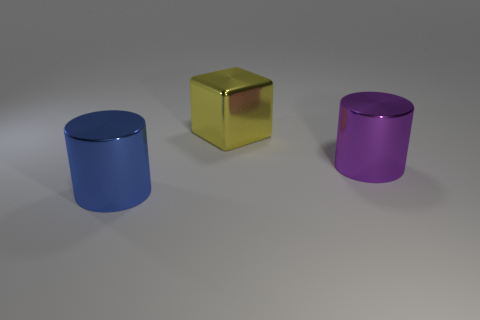Add 1 yellow cylinders. How many objects exist? 4 Subtract all blue cylinders. How many cylinders are left? 1 Subtract 0 brown cylinders. How many objects are left? 3 Subtract all cubes. How many objects are left? 2 Subtract 1 cubes. How many cubes are left? 0 Subtract all purple blocks. Subtract all red spheres. How many blocks are left? 1 Subtract all brown cylinders. How many red blocks are left? 0 Subtract all blue matte things. Subtract all big purple shiny cylinders. How many objects are left? 2 Add 1 blocks. How many blocks are left? 2 Add 2 large blue metallic things. How many large blue metallic things exist? 3 